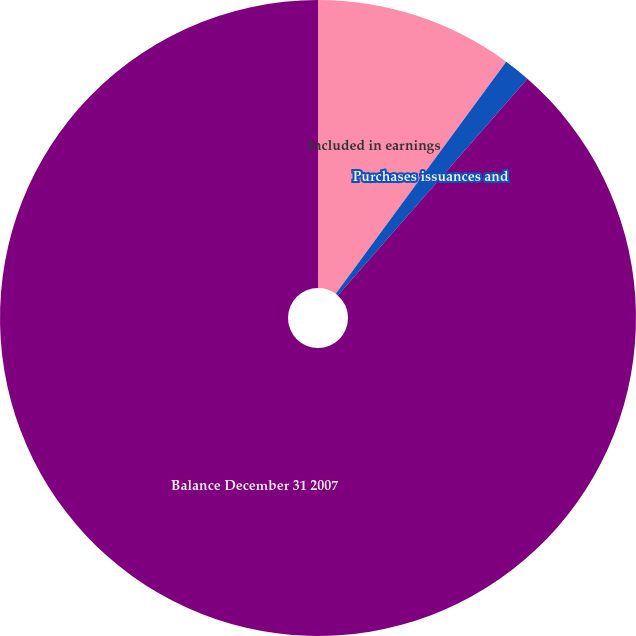Convert chart to OTSL. <chart><loc_0><loc_0><loc_500><loc_500><pie_chart><fcel>Included in earnings<fcel>Purchases issuances and<fcel>Balance December 31 2007<nl><fcel>10.08%<fcel>1.36%<fcel>88.55%<nl></chart> 